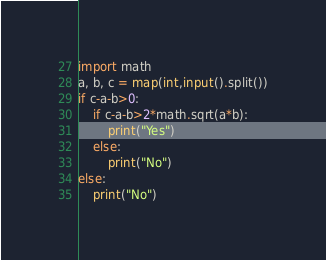Convert code to text. <code><loc_0><loc_0><loc_500><loc_500><_Python_>import math
a, b, c = map(int,input().split())
if c-a-b>0:
    if c-a-b>2*math.sqrt(a*b):
        print("Yes")
    else:
        print("No")
else:
    print("No")</code> 